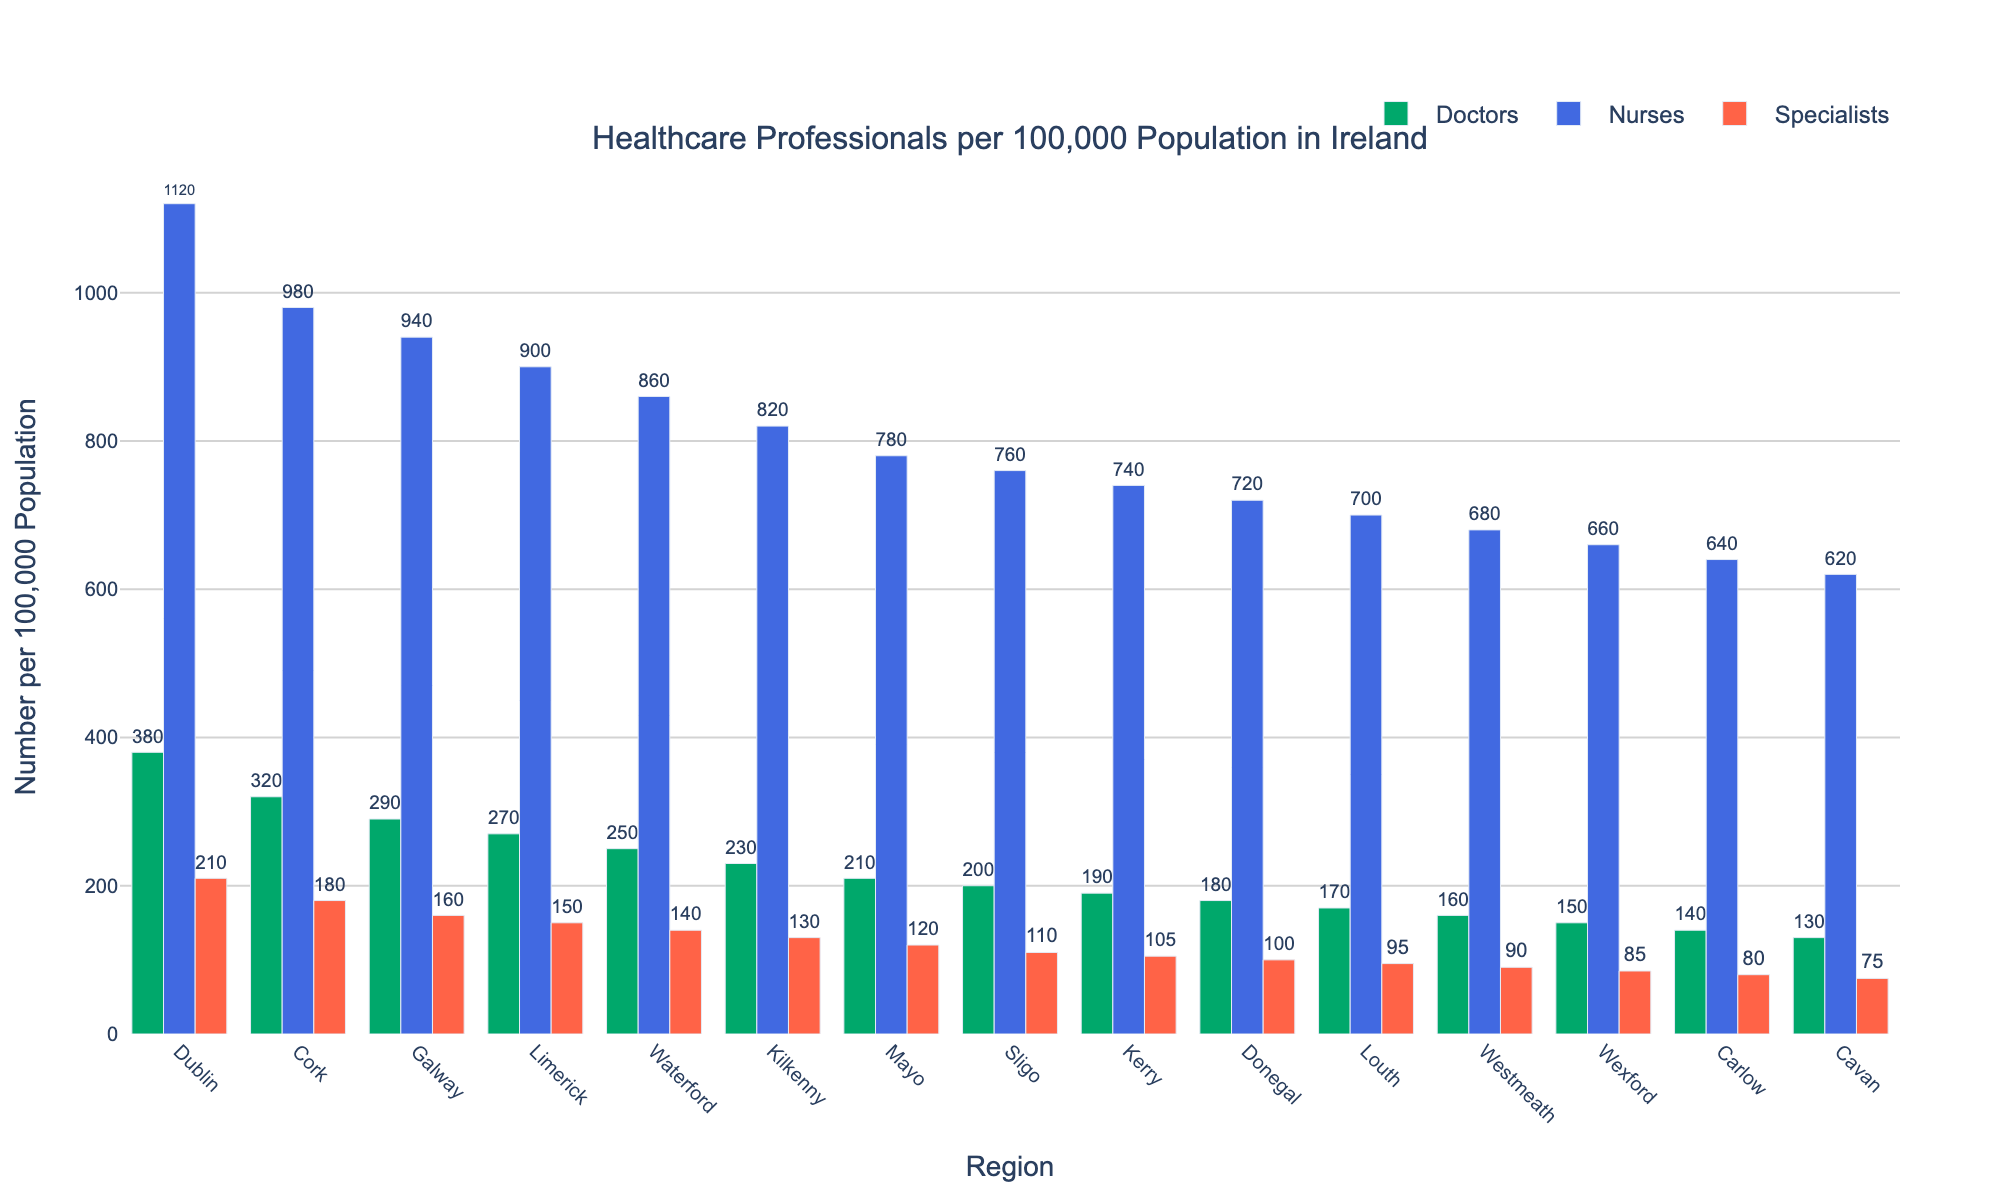Which region has the highest number of doctors per 100,000 population? Identify the tallest green bar in the figure which represents doctors. The tallest green bar is in Dublin.
Answer: Dublin How does the number of nurses per 100,000 in Cork compare to that in Waterford? Look at the height of the blue bars for Cork and Waterford. The blue bar for Cork is higher than that for Waterford, indicating more nurses per capita in Cork.
Answer: Cork has more nurses What's the difference in the number of specialists per 100,000 between Dublin and Donegal? Identify the tallest and shortest red bars, which correspond to Dublin and Donegal. The difference is calculated by subtracting the value for Donegal from Dublin: 210 - 100.
Answer: 110 Which region has the lowest number of healthcare professionals (total of doctors, nurses, and specialists) per 100,000 population? Sum the heights of green, blue, and red bars for each region. The region with the smallest combined height is Cavan.
Answer: Cavan What is the average number of doctors per 100,000 population across all regions? Sum the doctors per 100k for all regions and divide by the number of regions (15): (380 + 320 + 290 + 270 + 250 + 230 + 210 + 200 + 190 + 180 + 170 + 160 + 150 + 140 + 130) / 15. The sum is 3270, so the average is 3270 / 15.
Answer: 218 How does Galway's number of specialists per 100,000 compare to the overall average of specialists per 100,000 across all regions? Calculate the overall average of specialists by summing the specialists per 100k for all regions and dividing by the number of regions: (210 + 180 + 160 + 150 + 140 + 130 + 120 + 110 + 105 + 100 + 95 + 90 + 85 + 80 + 75) / 15. The sum is 1830, and the average is 1830 / 15 = 122. Compare this to Galway's value, which is 160.
Answer: Galway has more specialists In which region are the counts of doctors, nurses, and specialists most evenly distributed? Identify the region where the heights of the green, blue, and red bars are closest in value. This is subjective but visually Sligo’s bars appear to be the most evenly distributed.
Answer: Sligo What's the total number of healthcare professionals per 100,000 population in Limerick? Sum the doctors, nurses, and specialists per 100k in Limerick: 270 + 900 + 150.
Answer: 1320 